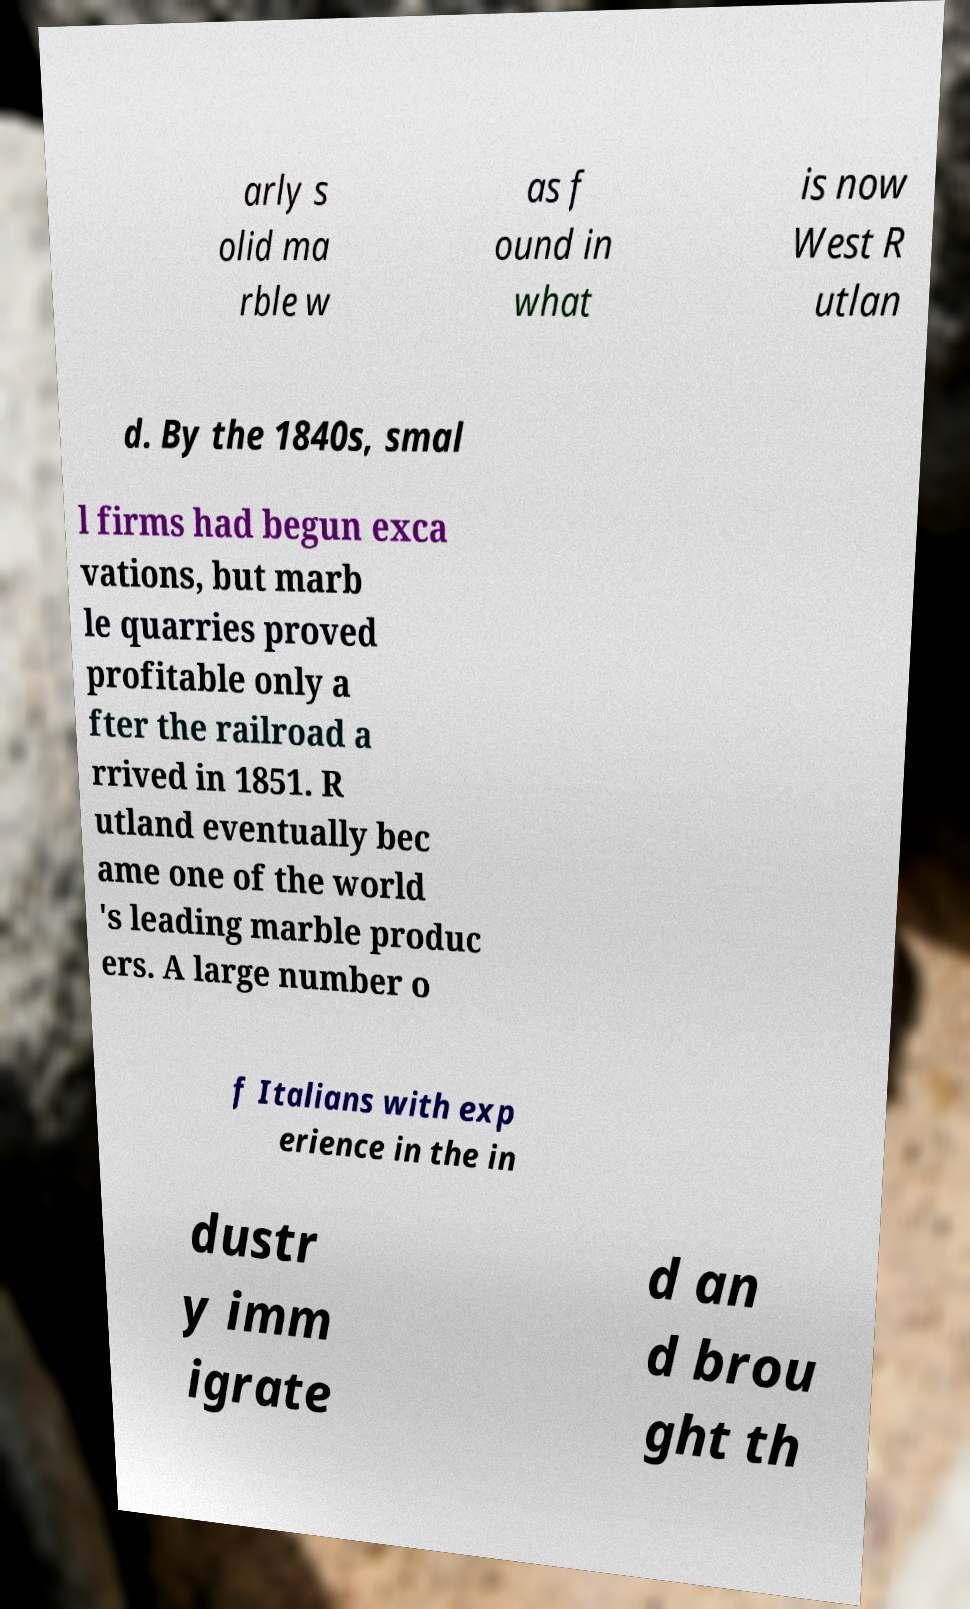Could you extract and type out the text from this image? arly s olid ma rble w as f ound in what is now West R utlan d. By the 1840s, smal l firms had begun exca vations, but marb le quarries proved profitable only a fter the railroad a rrived in 1851. R utland eventually bec ame one of the world 's leading marble produc ers. A large number o f Italians with exp erience in the in dustr y imm igrate d an d brou ght th 